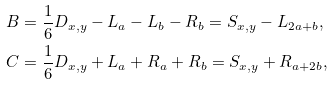<formula> <loc_0><loc_0><loc_500><loc_500>B & = \frac { 1 } { 6 } D _ { x , y } - L _ { a } - L _ { b } - R _ { b } = S _ { x , y } - L _ { 2 a + b } , \\ C & = \frac { 1 } { 6 } D _ { x , y } + L _ { a } + R _ { a } + R _ { b } = S _ { x , y } + R _ { a + 2 b } ,</formula> 